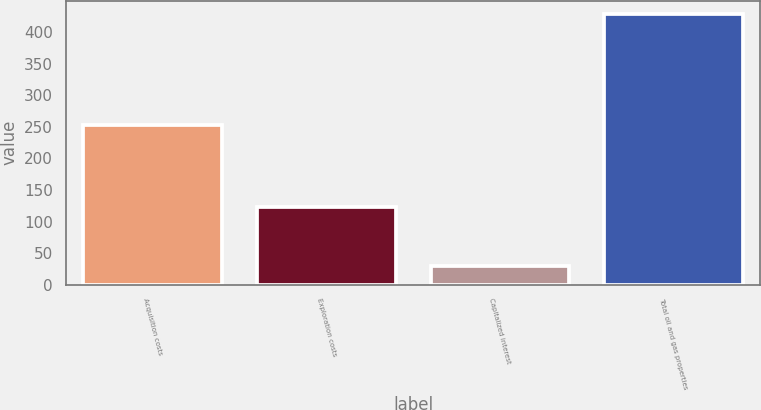<chart> <loc_0><loc_0><loc_500><loc_500><bar_chart><fcel>Acquisition costs<fcel>Exploration costs<fcel>Capitalized interest<fcel>Total oil and gas properties<nl><fcel>253<fcel>123<fcel>30<fcel>428<nl></chart> 